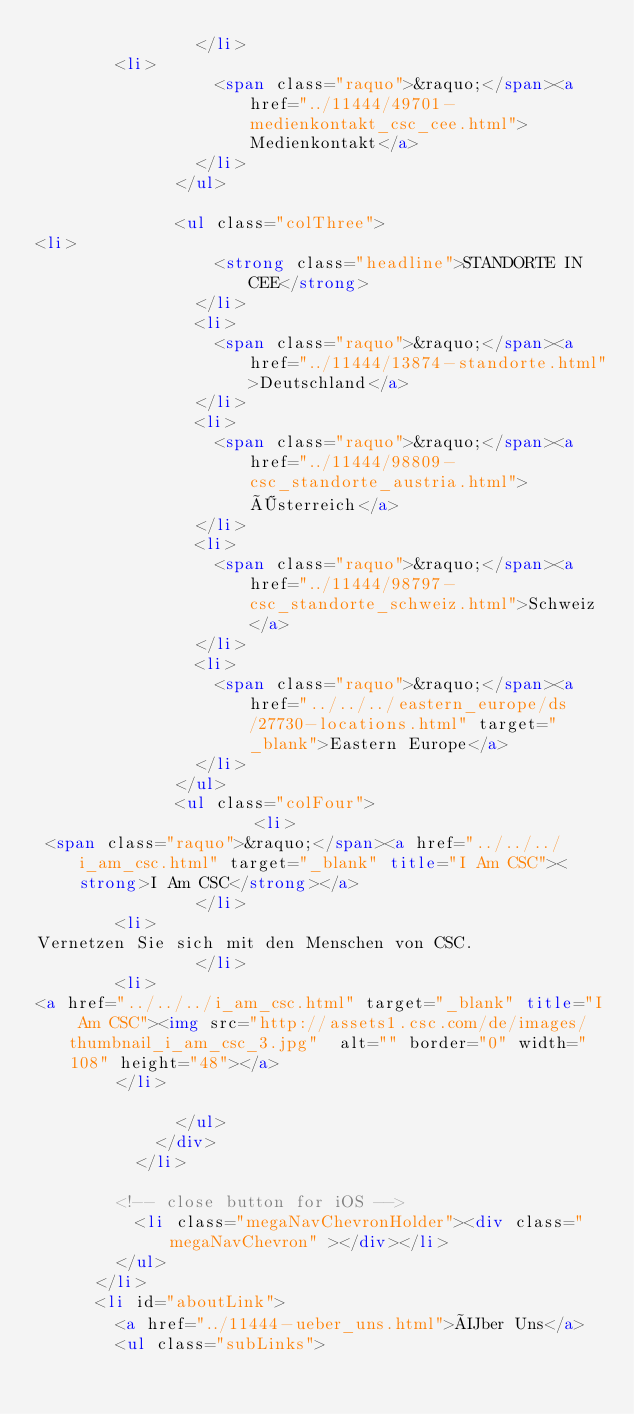<code> <loc_0><loc_0><loc_500><loc_500><_HTML_>                </li>
				<li>
                  <span class="raquo">&raquo;</span><a href="../11444/49701-medienkontakt_csc_cee.html">Medienkontakt</a>
                </li>
              </ul>

              <ul class="colThree">
<li>
                  <strong class="headline">STANDORTE IN CEE</strong>
                </li>
                <li>
                  <span class="raquo">&raquo;</span><a href="../11444/13874-standorte.html">Deutschland</a>
                </li>
                <li>
                  <span class="raquo">&raquo;</span><a href="../11444/98809-csc_standorte_austria.html">Österreich</a>
                </li>
                <li>
                  <span class="raquo">&raquo;</span><a href="../11444/98797-csc_standorte_schweiz.html">Schweiz</a>
                </li>
                <li>
                  <span class="raquo">&raquo;</span><a href="../../../eastern_europe/ds/27730-locations.html" target="_blank">Eastern Europe</a>
                </li>
              </ul>
              <ul class="colFour">
                			<li>
 <span class="raquo">&raquo;</span><a href="../../../i_am_csc.html" target="_blank" title="I Am CSC"><strong>I Am CSC</strong></a>
                </li>
				<li>
Vernetzen Sie sich mit den Menschen von CSC.
                </li>
				<li>
<a href="../../../i_am_csc.html" target="_blank" title="I Am CSC"><img src="http://assets1.csc.com/de/images/thumbnail_i_am_csc_3.jpg"  alt="" border="0" width="108" height="48"></a>
				</li> 

              </ul>
            </div>
          </li>

        <!-- close button for iOS -->
          <li class="megaNavChevronHolder"><div class="megaNavChevron" ></div></li>
        </ul>
      </li>
      <li id="aboutLink">
        <a href="../11444-ueber_uns.html">Über Uns</a>
        <ul class="subLinks"></code> 